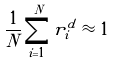Convert formula to latex. <formula><loc_0><loc_0><loc_500><loc_500>\frac { 1 } { N } \sum _ { i = 1 } ^ { N } r _ { i } ^ { d } \approx 1</formula> 